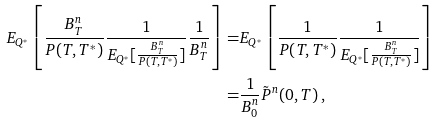<formula> <loc_0><loc_0><loc_500><loc_500>E _ { Q ^ { * } } \left [ \frac { B ^ { n } _ { T } } { P ( T , T ^ { * } ) } \frac { 1 } { E _ { Q ^ { * } } [ \frac { B ^ { n } _ { T } } { P ( T , T ^ { * } ) } ] } \frac { 1 } { B ^ { n } _ { T } } \right ] = & E _ { Q ^ { * } } \left [ \frac { 1 } { P ( T , T ^ { * } ) } \frac { 1 } { E _ { Q ^ { * } } [ \frac { B ^ { n } _ { T } } { P ( T , T ^ { * } ) } ] } \right ] \\ = & \frac { 1 } { B ^ { n } _ { 0 } } \tilde { P } ^ { n } ( 0 , T ) \, ,</formula> 